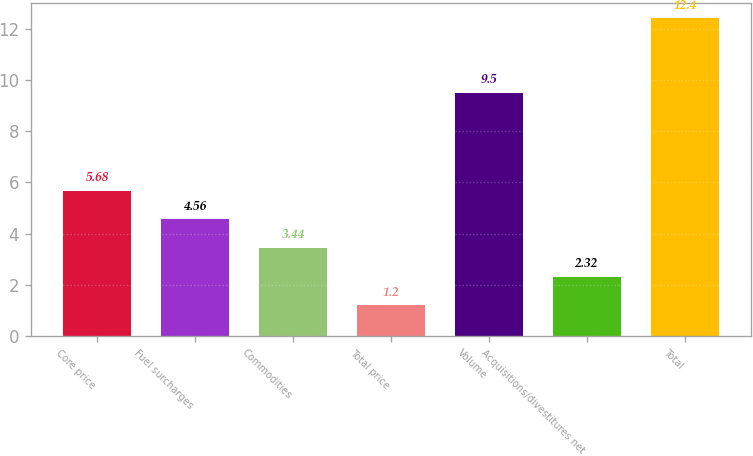Convert chart. <chart><loc_0><loc_0><loc_500><loc_500><bar_chart><fcel>Core price<fcel>Fuel surcharges<fcel>Commodities<fcel>Total price<fcel>Volume<fcel>Acquisitions/divestitures net<fcel>Total<nl><fcel>5.68<fcel>4.56<fcel>3.44<fcel>1.2<fcel>9.5<fcel>2.32<fcel>12.4<nl></chart> 